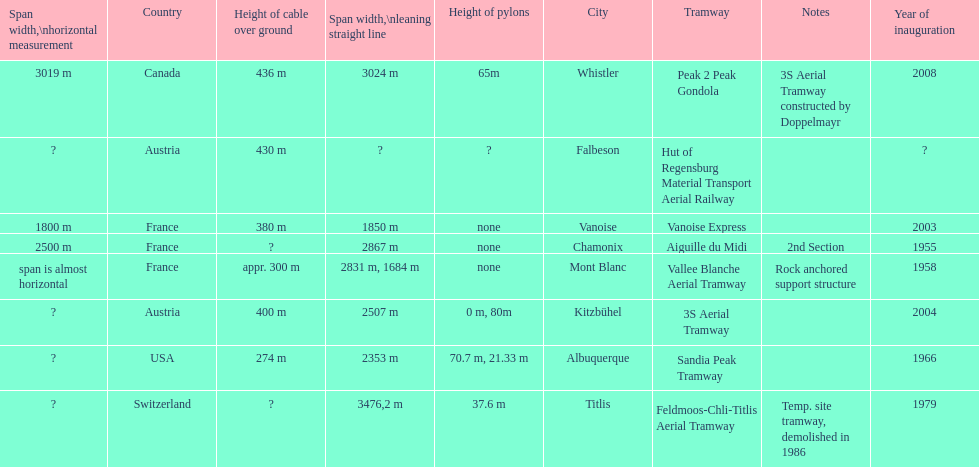Could you help me parse every detail presented in this table? {'header': ['Span width,\\nhorizontal measurement', 'Country', 'Height of cable over ground', 'Span\xa0width,\\nleaning straight line', 'Height of pylons', 'City', 'Tramway', 'Notes', 'Year of inauguration'], 'rows': [['3019 m', 'Canada', '436 m', '3024 m', '65m', 'Whistler', 'Peak 2 Peak Gondola', '3S Aerial Tramway constructed by Doppelmayr', '2008'], ['?', 'Austria', '430 m', '?', '?', 'Falbeson', 'Hut of Regensburg Material Transport Aerial Railway', '', '?'], ['1800 m', 'France', '380 m', '1850 m', 'none', 'Vanoise', 'Vanoise Express', '', '2003'], ['2500 m', 'France', '?', '2867 m', 'none', 'Chamonix', 'Aiguille du Midi', '2nd Section', '1955'], ['span is almost horizontal', 'France', 'appr. 300 m', '2831 m, 1684 m', 'none', 'Mont Blanc', 'Vallee Blanche Aerial Tramway', 'Rock anchored support structure', '1958'], ['?', 'Austria', '400 m', '2507 m', '0 m, 80m', 'Kitzbühel', '3S Aerial Tramway', '', '2004'], ['?', 'USA', '274 m', '2353 m', '70.7 m, 21.33 m', 'Albuquerque', 'Sandia Peak Tramway', '', '1966'], ['?', 'Switzerland', '?', '3476,2 m', '37.6 m', 'Titlis', 'Feldmoos-Chli-Titlis Aerial Tramway', 'Temp. site tramway, demolished in 1986', '1979']]} How much longer is the peak 2 peak gondola than the 32 aerial tramway? 517. 